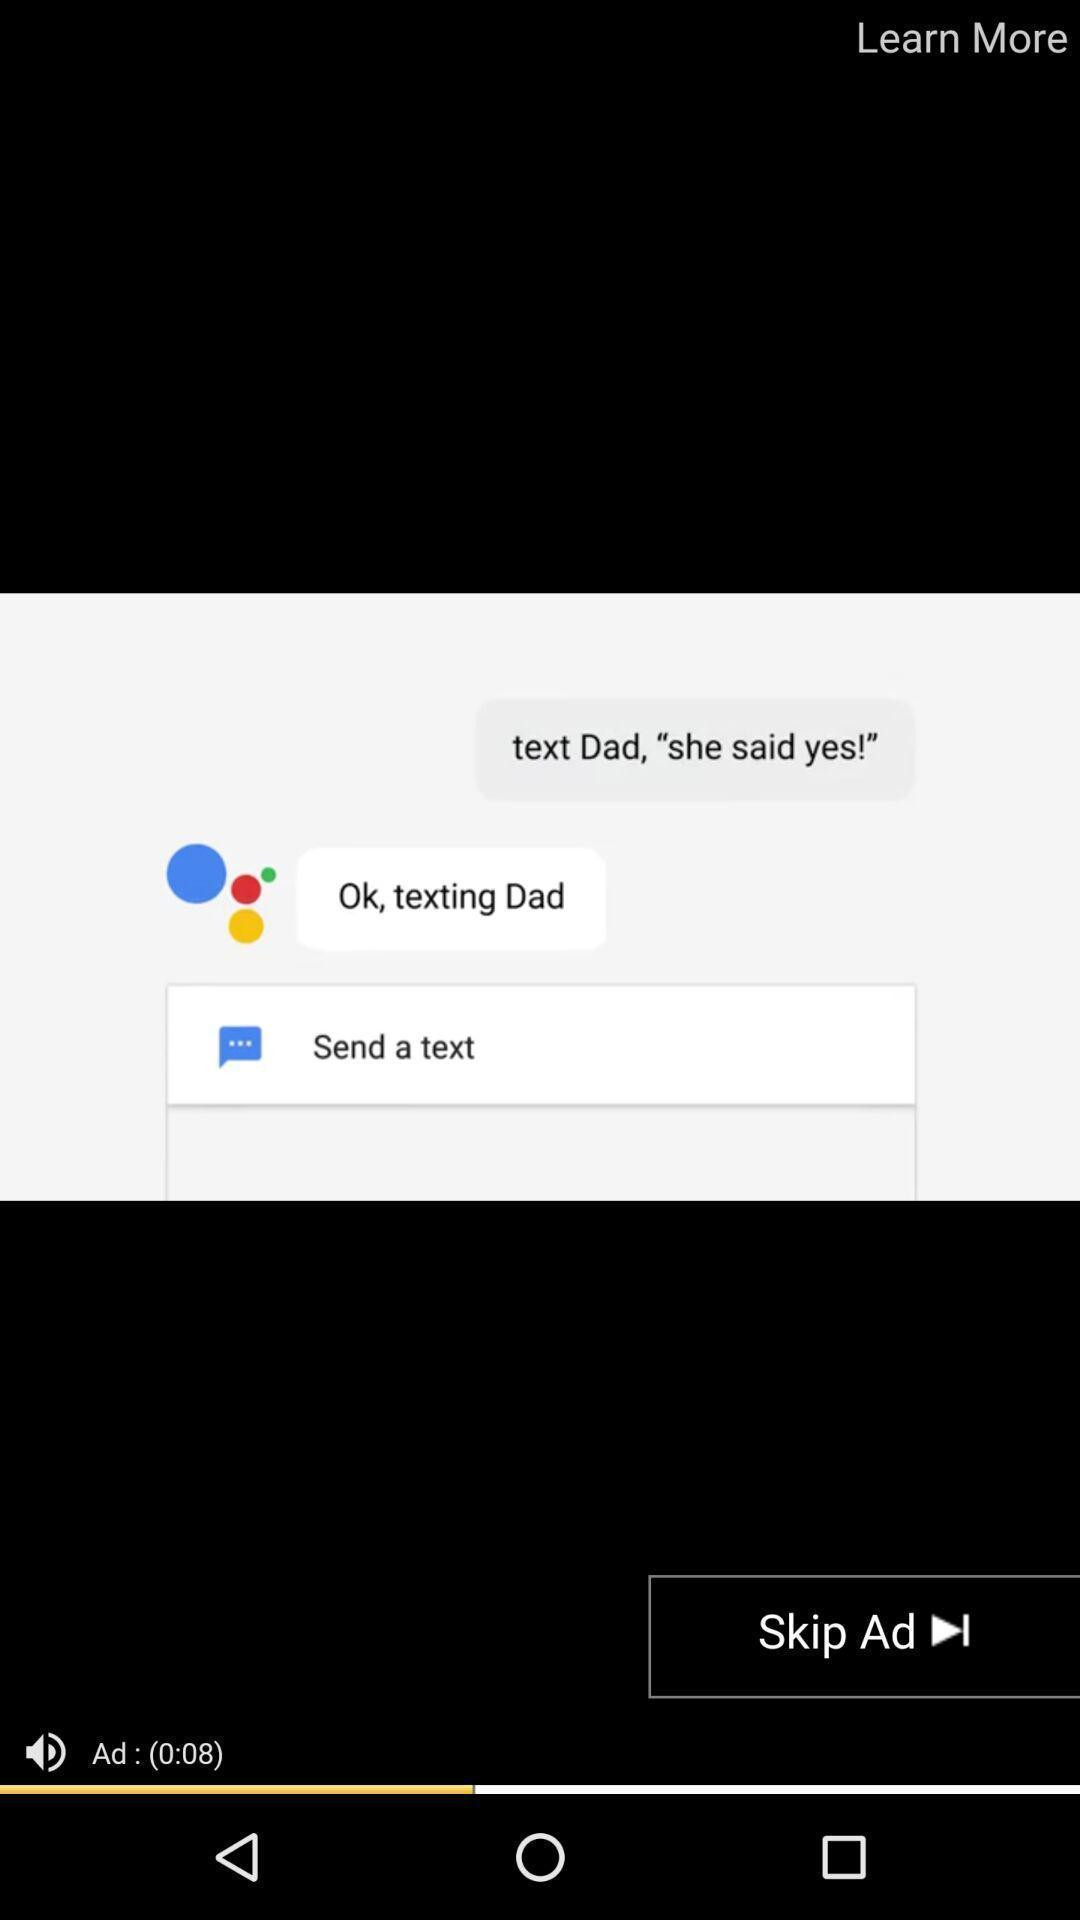Give me a summary of this screen capture. Screen shows an advertisement on an app. 